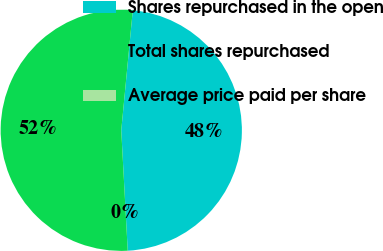<chart> <loc_0><loc_0><loc_500><loc_500><pie_chart><fcel>Shares repurchased in the open<fcel>Total shares repurchased<fcel>Average price paid per share<nl><fcel>47.62%<fcel>52.38%<fcel>0.0%<nl></chart> 